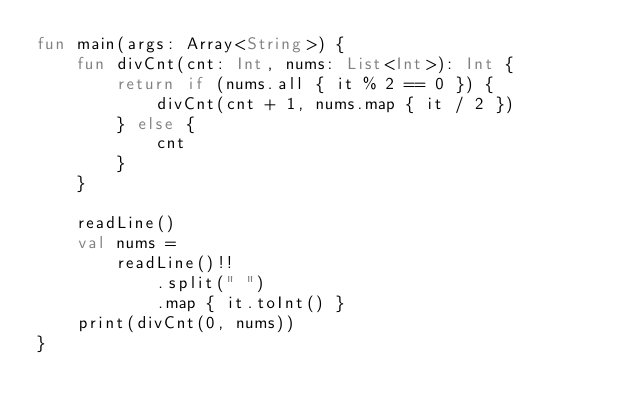<code> <loc_0><loc_0><loc_500><loc_500><_Kotlin_>fun main(args: Array<String>) {
    fun divCnt(cnt: Int, nums: List<Int>): Int {
        return if (nums.all { it % 2 == 0 }) {
            divCnt(cnt + 1, nums.map { it / 2 })
        } else {
            cnt
        }
    }

    readLine()
    val nums =
        readLine()!!
            .split(" ")
            .map { it.toInt() }
    print(divCnt(0, nums))
}</code> 